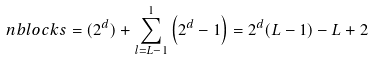<formula> <loc_0><loc_0><loc_500><loc_500>\ n b l o c k s = ( 2 ^ { d } ) + \sum _ { l = L - 1 } ^ { 1 } { \left ( 2 ^ { d } - 1 \right ) } = 2 ^ { d } ( L - 1 ) - L + 2</formula> 